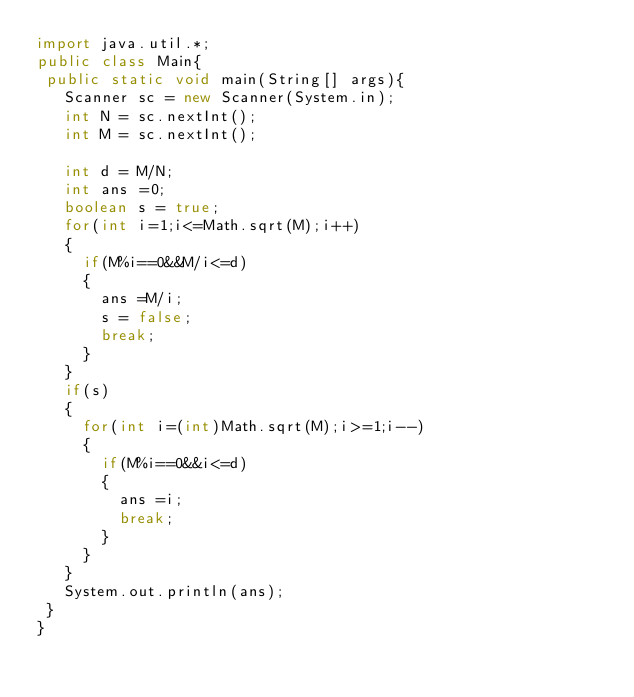Convert code to text. <code><loc_0><loc_0><loc_500><loc_500><_Java_>import java.util.*;
public class Main{
 public static void main(String[] args){
   Scanner sc = new Scanner(System.in);
   int N = sc.nextInt();
   int M = sc.nextInt();
   
   int d = M/N;
   int ans =0;
   boolean s = true;
   for(int i=1;i<=Math.sqrt(M);i++)
   {
     if(M%i==0&&M/i<=d)
     {
       ans =M/i;
       s = false;
       break;
     }
   }
   if(s)
   {
     for(int i=(int)Math.sqrt(M);i>=1;i--)
     {
       if(M%i==0&&i<=d)
       {
         ans =i;
         break;
       }
     }
   }
   System.out.println(ans);   
 }
}</code> 